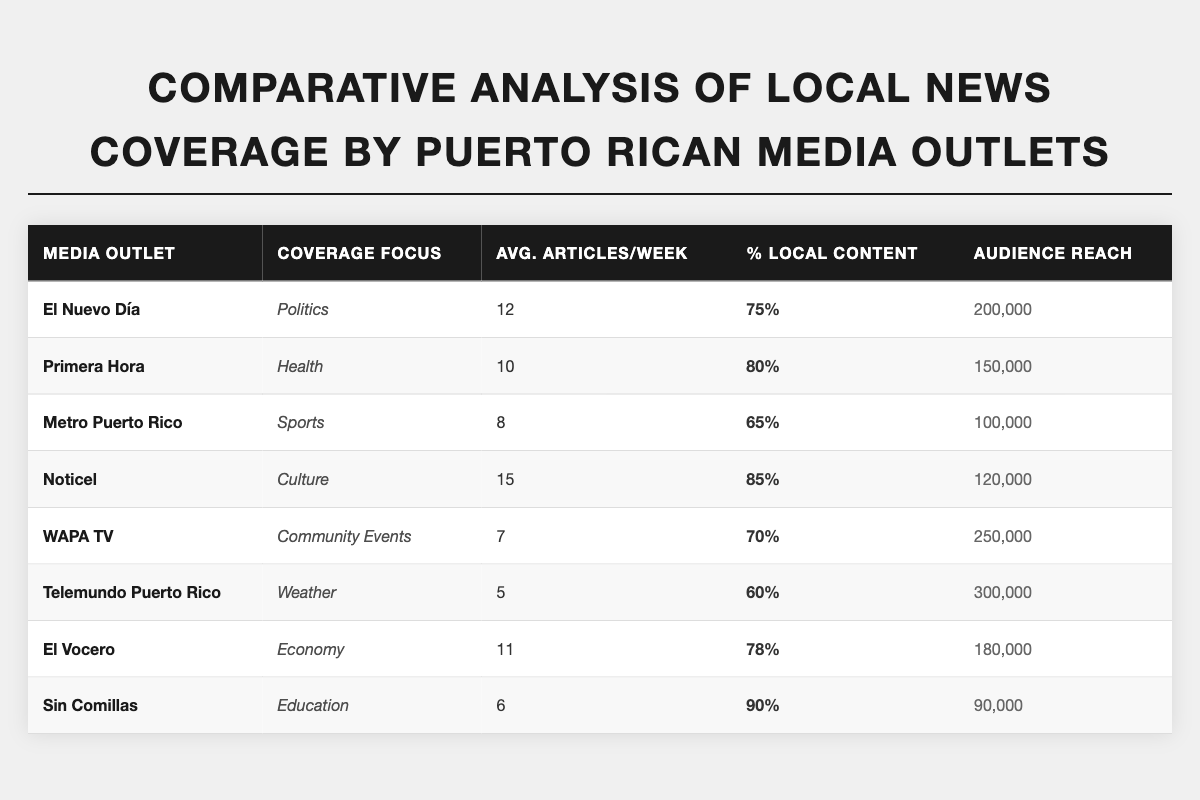What is the average number of articles per week published by Noticel? Noticel publishes an average of 15 articles per week, as indicated in the table under "Avg. Articles/Week" for that media outlet.
Answer: 15 Which media outlet has the highest audience reach? Telemundo Puerto Rico has the highest audience reach of 300,000, as shown in the "Audience Reach" column.
Answer: 300,000 What percentage of local content does Sin Comillas produce? Sin Comillas produces 90% local content, as stated in the "% Local Content" column.
Answer: 90% How many articles per week do WAPA TV and Metro Puerto Rico combined publish? WAPA TV publishes 7 articles and Metro Puerto Rico publishes 8 articles per week. Combined, they publish 7 + 8 = 15 articles per week.
Answer: 15 Is the average percentage of local content higher for Noticel or El Vocero? Noticel has 85% local content, while El Vocero has 78%. Since 85% is greater than 78%, Noticel has a higher average percentage of local content than El Vocero.
Answer: True What is the total audience reach of El Nuevo Día, Primera Hora, and El Vocero? El Nuevo Día has an audience reach of 200,000, Primera Hora has 150,000, and El Vocero has 180,000. Adding these values gives: 200,000 + 150,000 + 180,000 = 530,000.
Answer: 530,000 Which media outlet focuses on Culture and what is its average articles per week? Noticel focuses on Culture and publishes an average of 15 articles per week, as indicated in the "Coverage Focus" and "Avg. Articles/Week" columns.
Answer: Noticel, 15 Is the percentage of local content for Telemundo Puerto Rico higher than that of Metro Puerto Rico? Telemundo Puerto Rico has a local content percentage of 60%, while Metro Puerto Rico has 65%. Since 60% is less than 65%, Telemundo Puerto Rico's percentage is not higher.
Answer: False What is the difference in average articles per week between El Nuevo Día and WAPA TV? El Nuevo Día publishes 12 articles per week while WAPA TV publishes 7. The difference is 12 - 7 = 5 articles per week.
Answer: 5 Which media outlet publishes the least number of articles per week and how many does it publish? Telemundo Puerto Rico publishes the least number of articles, with an average of 5 articles per week, as shown in the "Avg. Articles/Week" column.
Answer: Telemundo Puerto Rico, 5 